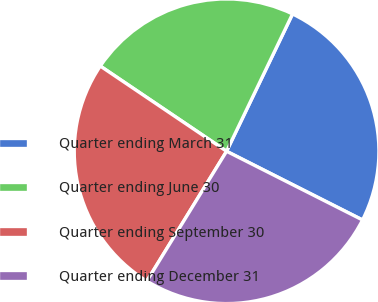<chart> <loc_0><loc_0><loc_500><loc_500><pie_chart><fcel>Quarter ending March 31<fcel>Quarter ending June 30<fcel>Quarter ending September 30<fcel>Quarter ending December 31<nl><fcel>25.32%<fcel>22.68%<fcel>25.68%<fcel>26.32%<nl></chart> 